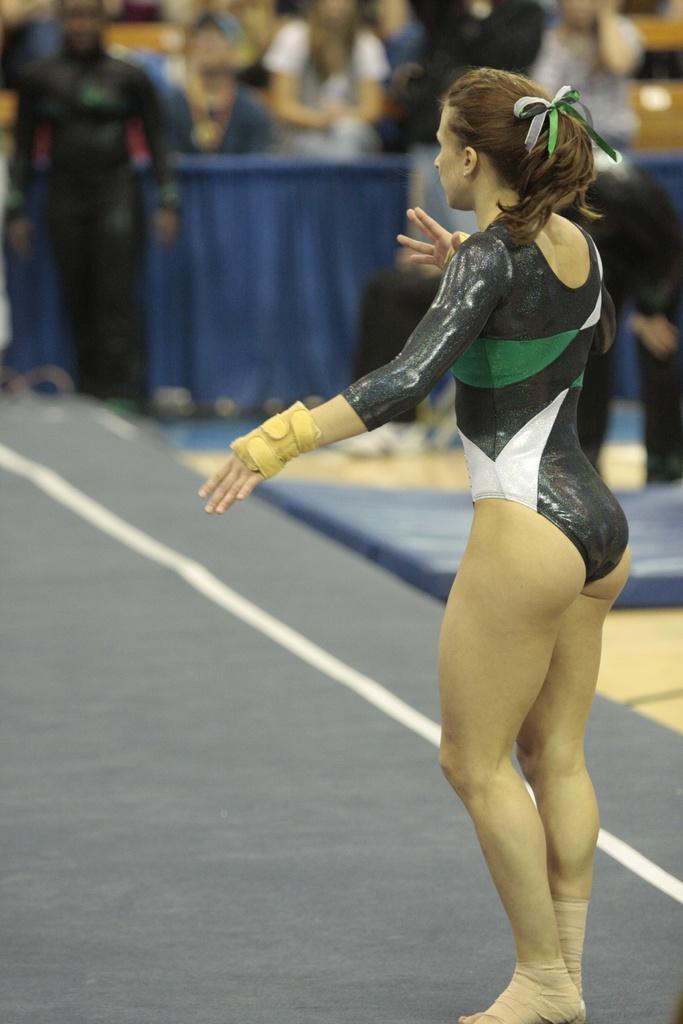Please provide a concise description of this image. On the right there is a woman standing on the platform. In the background the image is blur but we can see few people standing over here. 